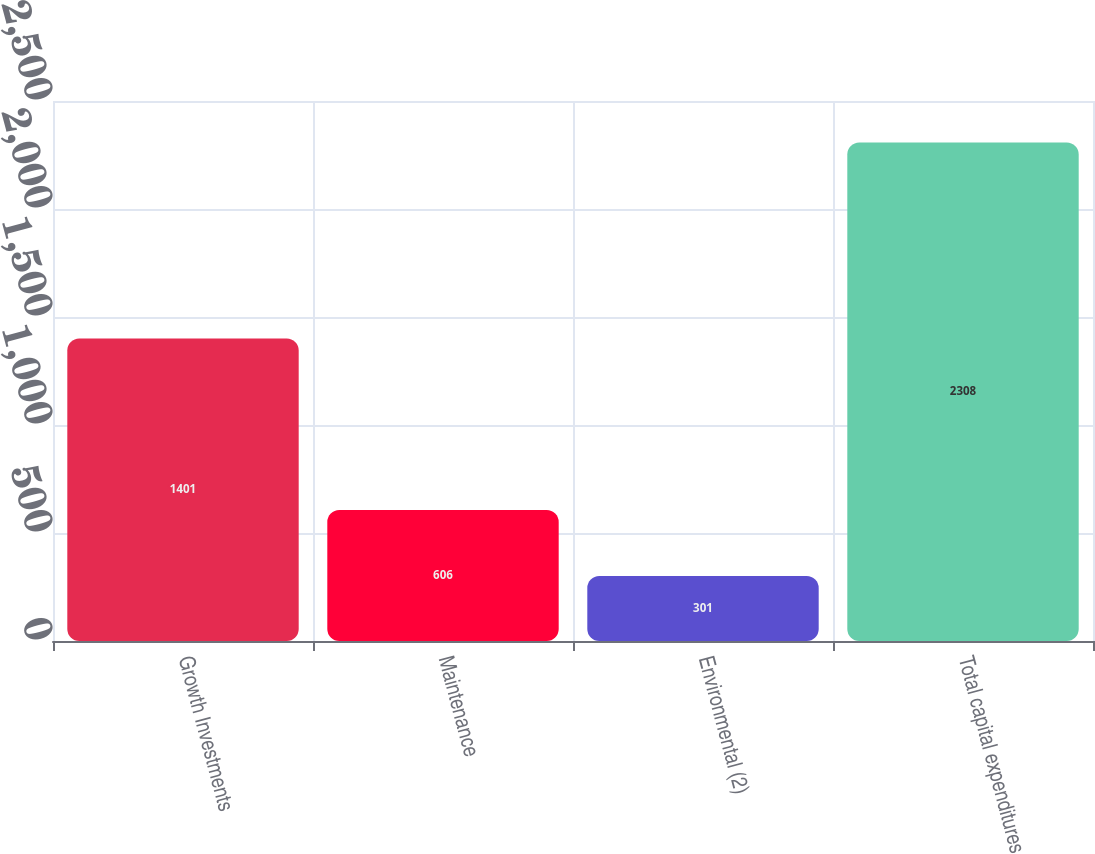<chart> <loc_0><loc_0><loc_500><loc_500><bar_chart><fcel>Growth Investments<fcel>Maintenance<fcel>Environmental (2)<fcel>Total capital expenditures<nl><fcel>1401<fcel>606<fcel>301<fcel>2308<nl></chart> 